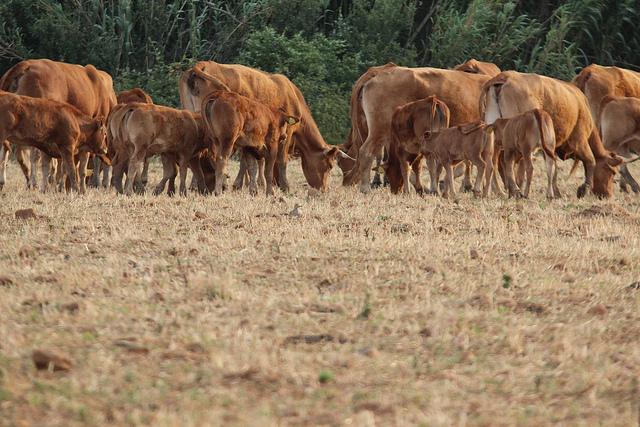Are all of these animals full grown?
Short answer required. No. Does any of the cows have horns?
Concise answer only. No. What are the animals eating?
Answer briefly. Grass. What animals are being shown?
Concise answer only. Cows. 